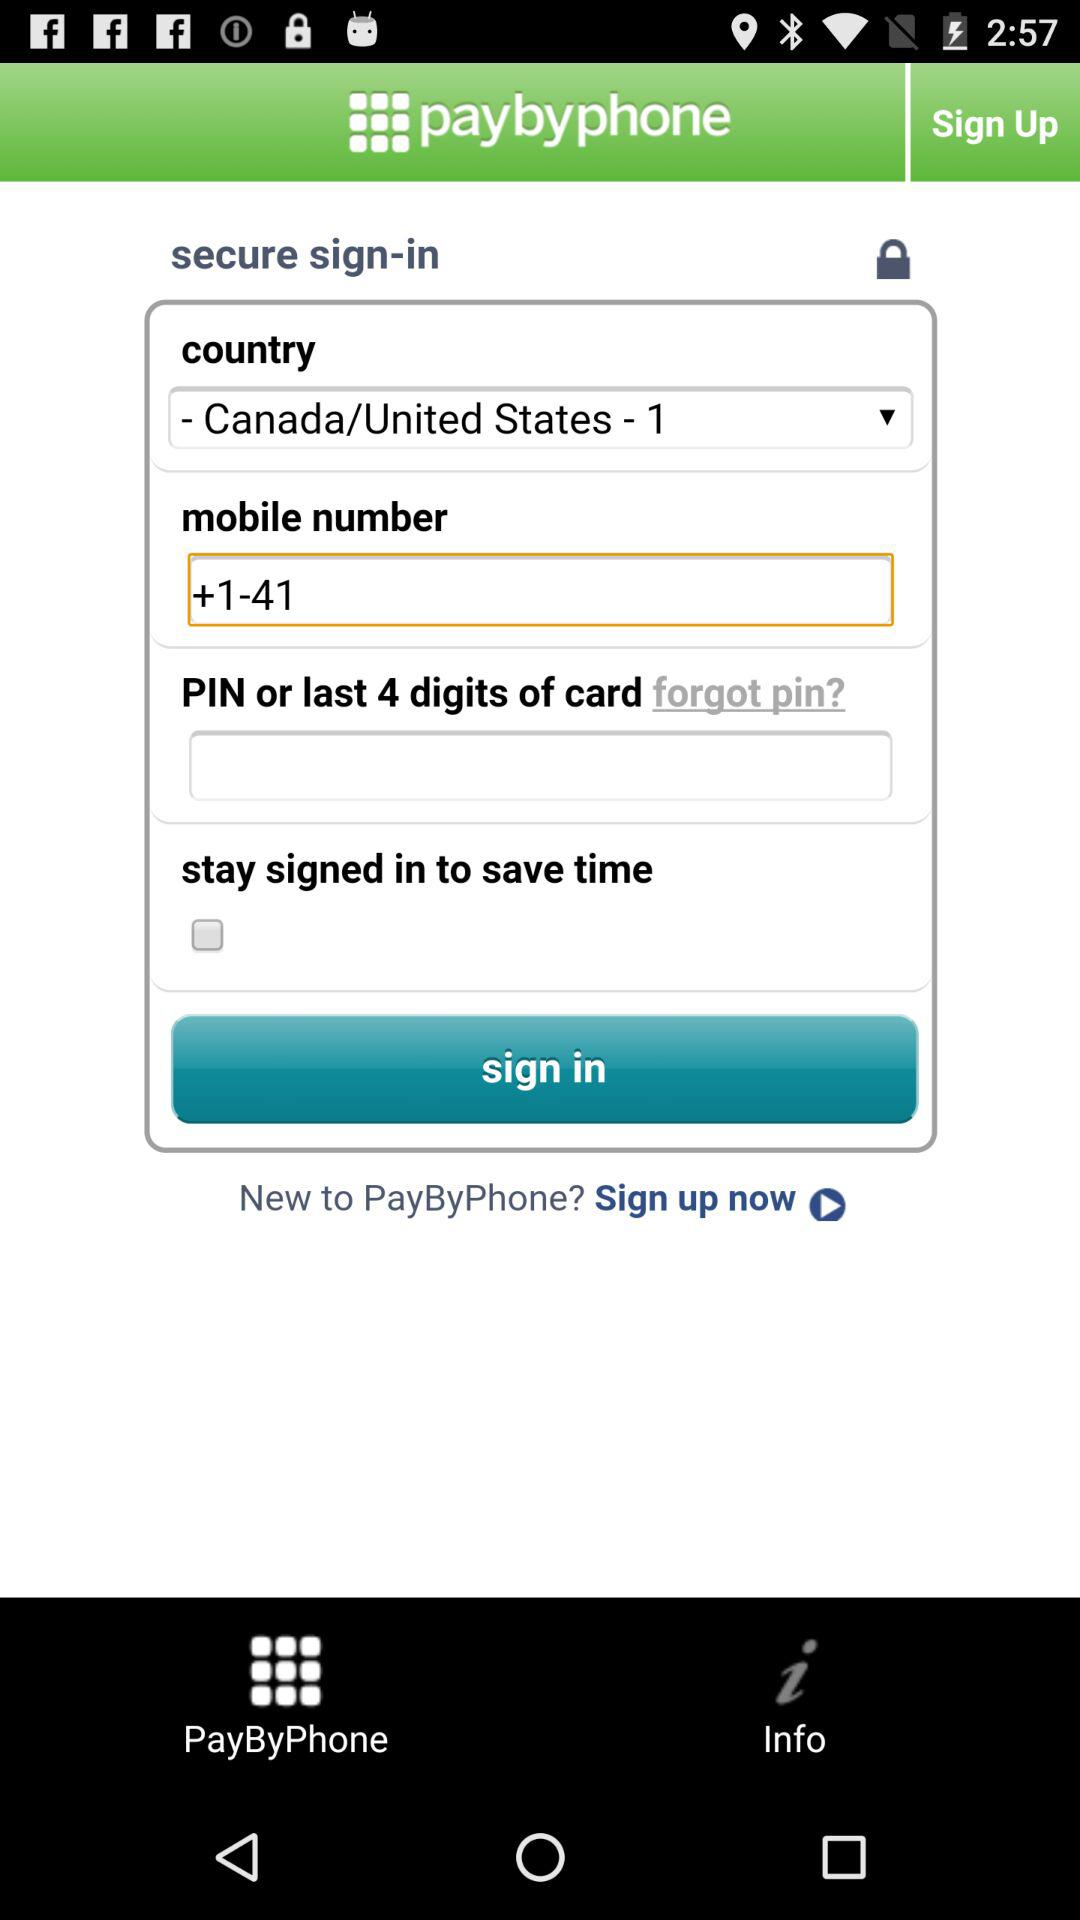What is the name of the application? The name of the application is "paybyphone". 